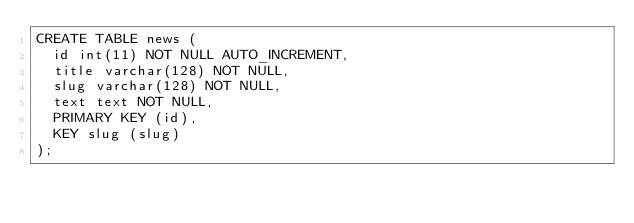Convert code to text. <code><loc_0><loc_0><loc_500><loc_500><_SQL_>CREATE TABLE news (
  id int(11) NOT NULL AUTO_INCREMENT,
  title varchar(128) NOT NULL,
  slug varchar(128) NOT NULL,
  text text NOT NULL,
  PRIMARY KEY (id),
  KEY slug (slug)
);
</code> 